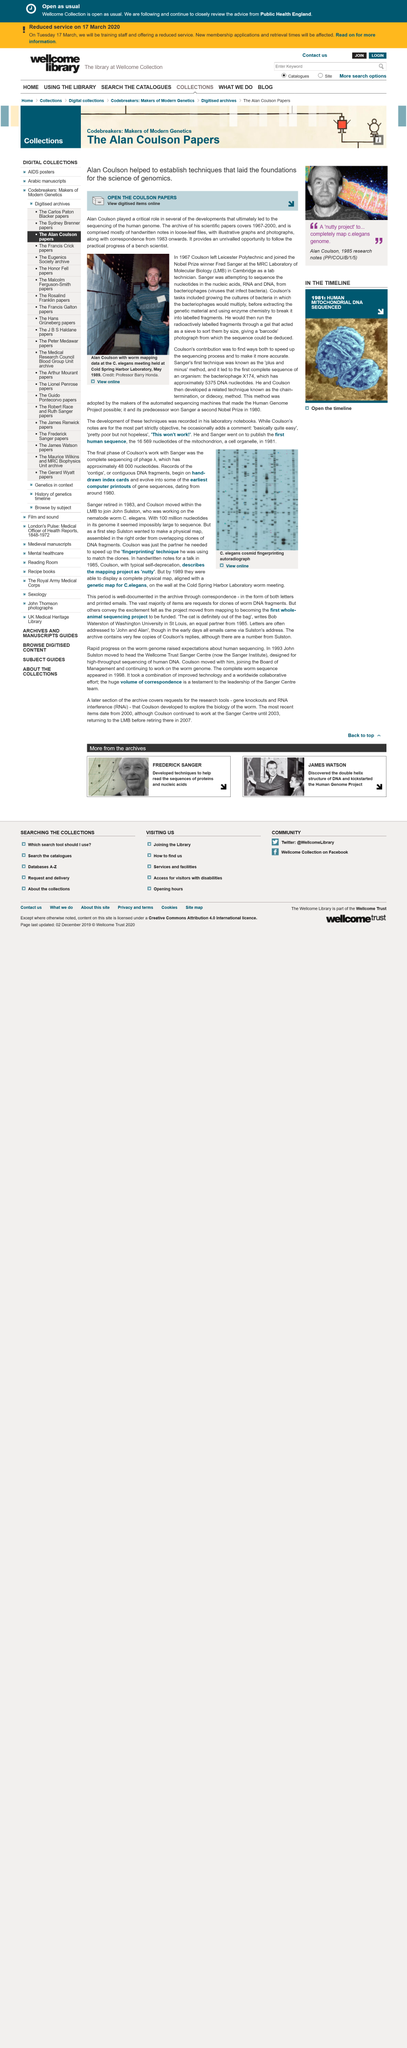Indicate a few pertinent items in this graphic. The image on the left depicts Coulson, and he is pictured in the image on the left. Fred Sanger was the Nobel prize winner that Coulson joined at the Laboratory of Molecular Biology. Coulson left Leicester Polytechnic in 1967. 